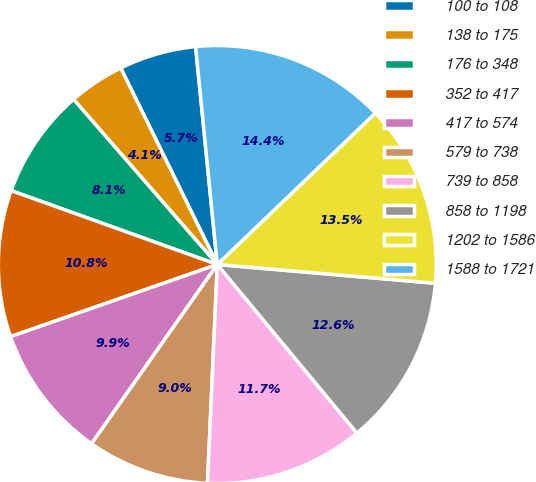Convert chart. <chart><loc_0><loc_0><loc_500><loc_500><pie_chart><fcel>100 to 108<fcel>138 to 175<fcel>176 to 348<fcel>352 to 417<fcel>417 to 574<fcel>579 to 738<fcel>739 to 858<fcel>858 to 1198<fcel>1202 to 1586<fcel>1588 to 1721<nl><fcel>5.69%<fcel>4.13%<fcel>8.12%<fcel>10.82%<fcel>9.92%<fcel>9.02%<fcel>11.72%<fcel>12.62%<fcel>13.52%<fcel>14.42%<nl></chart> 